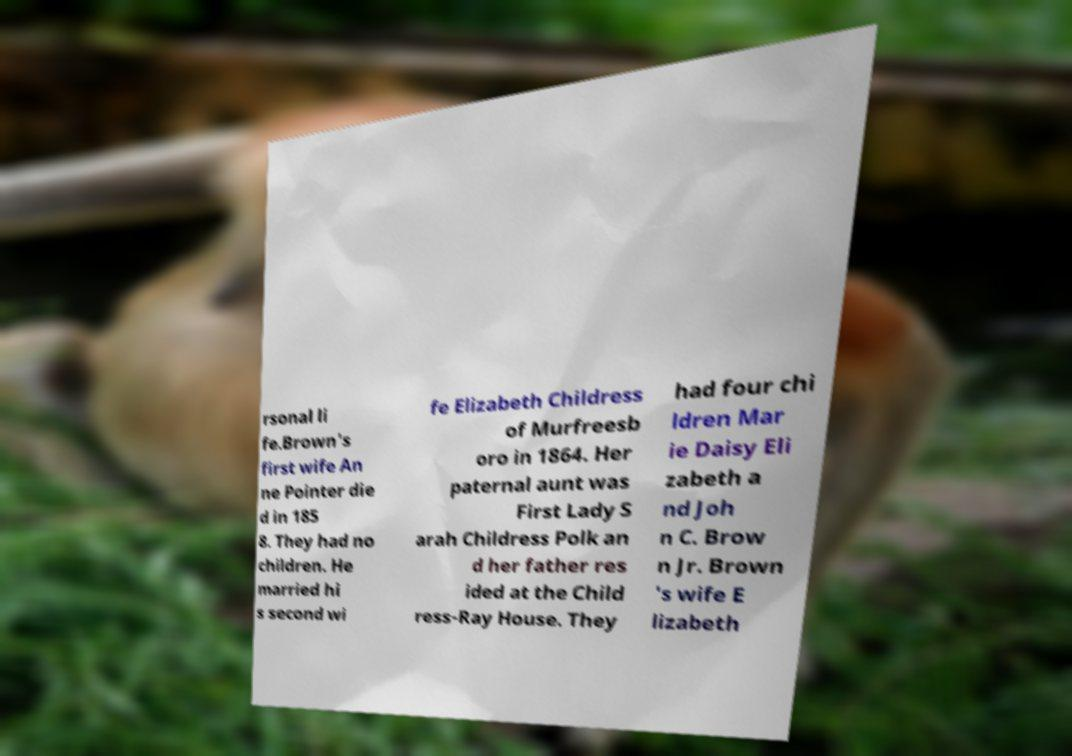Please read and relay the text visible in this image. What does it say? rsonal li fe.Brown's first wife An ne Pointer die d in 185 8. They had no children. He married hi s second wi fe Elizabeth Childress of Murfreesb oro in 1864. Her paternal aunt was First Lady S arah Childress Polk an d her father res ided at the Child ress-Ray House. They had four chi ldren Mar ie Daisy Eli zabeth a nd Joh n C. Brow n Jr. Brown 's wife E lizabeth 